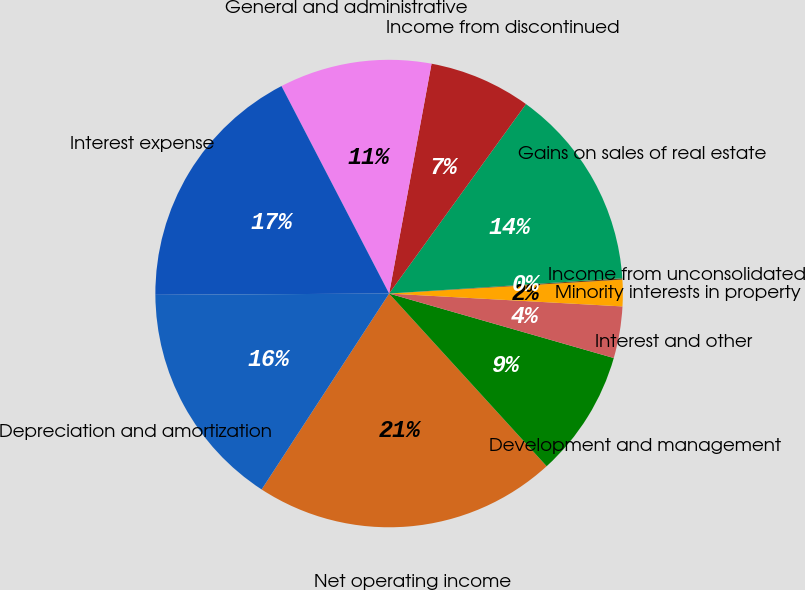<chart> <loc_0><loc_0><loc_500><loc_500><pie_chart><fcel>Net operating income<fcel>Development and management<fcel>Interest and other<fcel>Minority interests in property<fcel>Income from unconsolidated<fcel>Gains on sales of real estate<fcel>Income from discontinued<fcel>General and administrative<fcel>Interest expense<fcel>Depreciation and amortization<nl><fcel>20.95%<fcel>8.78%<fcel>3.57%<fcel>1.83%<fcel>0.09%<fcel>14.0%<fcel>7.05%<fcel>10.52%<fcel>17.47%<fcel>15.73%<nl></chart> 